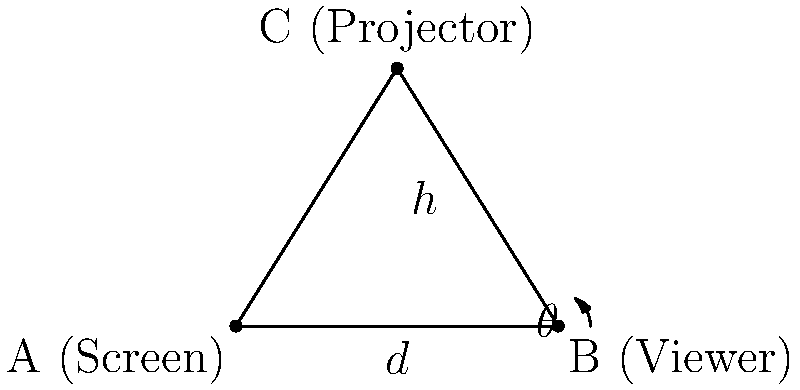In a movie theater, the screen (point A) is 10 meters wide, and a viewer (point B) is seated at the center of the screen's width. The projector (point C) is mounted 8 meters above the center of the screen. If the vertical distance from the viewer's eyes to the screen is 1.2 meters, what is the visual angle $\theta$ (in degrees) that the entire screen subtends in the viewer's field of view? To solve this problem, we'll follow these steps:

1) First, we need to find the distance $d$ from the viewer to the screen. We can do this using the Pythagorean theorem:

   $d^2 + 1.2^2 = 5^2$
   $d^2 = 25 - 1.44 = 23.56$
   $d = \sqrt{23.56} \approx 4.85$ meters

2) Now, we can calculate the visual angle $\theta$ using the formula:

   $\tan(\frac{\theta}{2}) = \frac{\text{half of screen width}}{d}$

3) Half of the screen width is 5 meters (as the total width is 10 meters). So:

   $\tan(\frac{\theta}{2}) = \frac{5}{4.85}$

4) To solve for $\theta$:

   $\frac{\theta}{2} = \arctan(\frac{5}{4.85})$
   $\theta = 2 \arctan(\frac{5}{4.85})$

5) Calculate the result:

   $\theta = 2 \arctan(\frac{5}{4.85}) \approx 2 \times 45.87° = 91.74°$

Therefore, the visual angle $\theta$ that the entire screen subtends in the viewer's field of view is approximately 91.74°.
Answer: $91.74°$ 